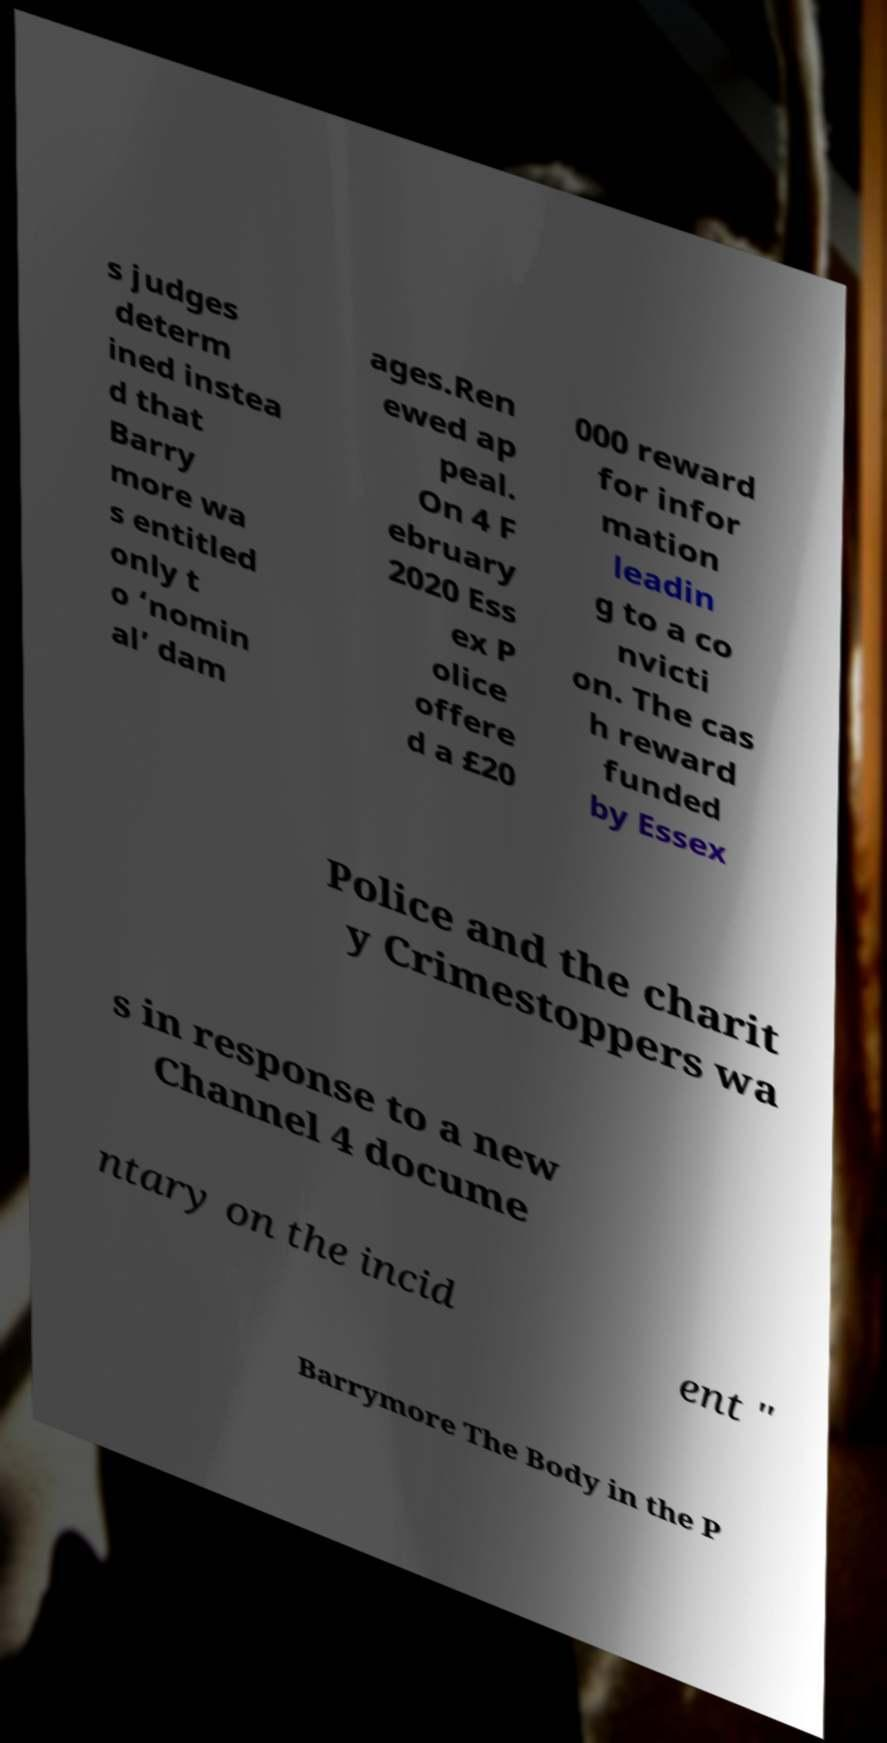There's text embedded in this image that I need extracted. Can you transcribe it verbatim? s judges determ ined instea d that Barry more wa s entitled only t o ‘nomin al’ dam ages.Ren ewed ap peal. On 4 F ebruary 2020 Ess ex P olice offere d a £20 000 reward for infor mation leadin g to a co nvicti on. The cas h reward funded by Essex Police and the charit y Crimestoppers wa s in response to a new Channel 4 docume ntary on the incid ent " Barrymore The Body in the P 